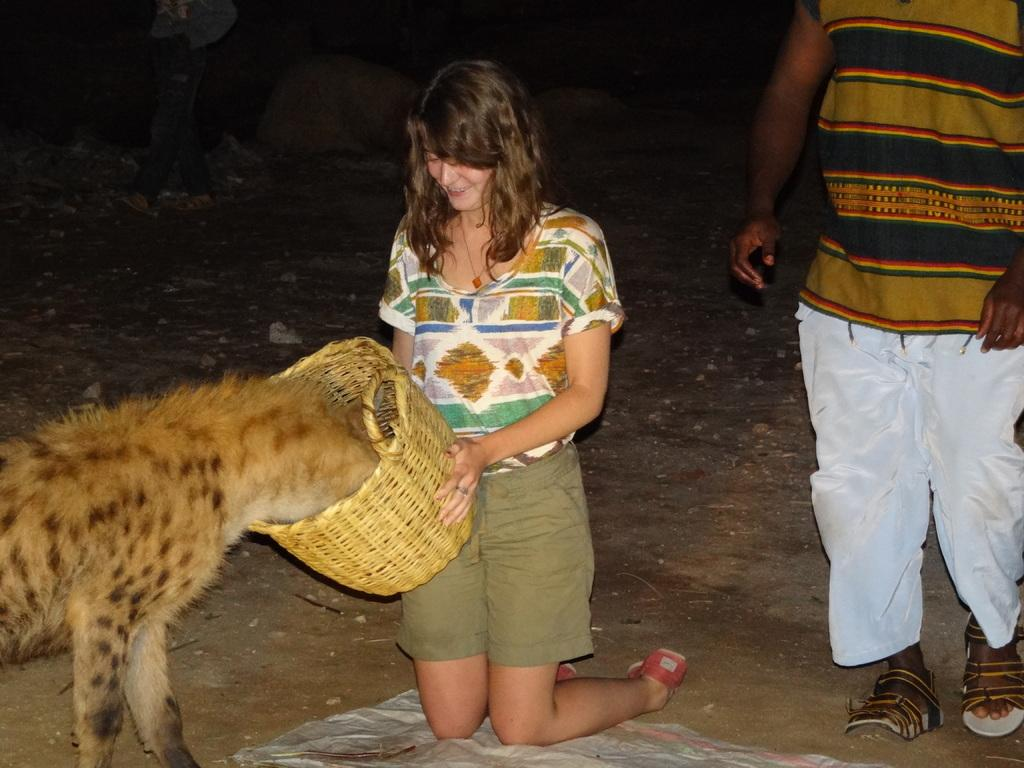Who is the main subject in the image? There is a woman in the image. What is the woman holding in the image? The woman is holding a basket. What is the woman doing with the animal? The woman is feeding an animal. Can you describe the other person in the image? There is another person standing in the image. What can be seen beneath the people in the image? The ground is visible in the image. How many legs does the sugar have in the image? There is no sugar present in the image, and therefore no legs can be attributed to it. 